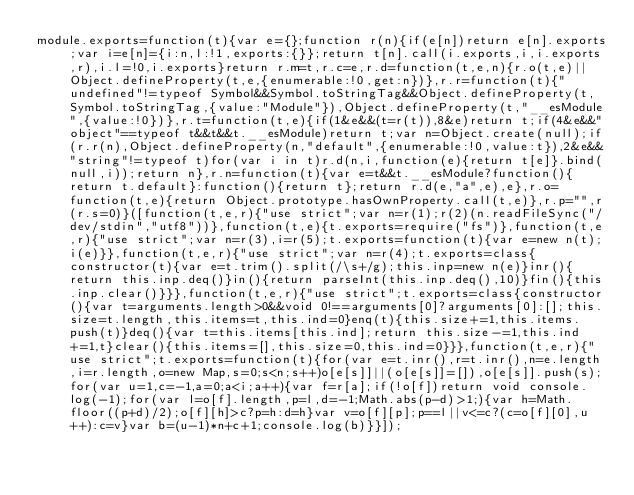<code> <loc_0><loc_0><loc_500><loc_500><_JavaScript_>module.exports=function(t){var e={};function r(n){if(e[n])return e[n].exports;var i=e[n]={i:n,l:!1,exports:{}};return t[n].call(i.exports,i,i.exports,r),i.l=!0,i.exports}return r.m=t,r.c=e,r.d=function(t,e,n){r.o(t,e)||Object.defineProperty(t,e,{enumerable:!0,get:n})},r.r=function(t){"undefined"!=typeof Symbol&&Symbol.toStringTag&&Object.defineProperty(t,Symbol.toStringTag,{value:"Module"}),Object.defineProperty(t,"__esModule",{value:!0})},r.t=function(t,e){if(1&e&&(t=r(t)),8&e)return t;if(4&e&&"object"==typeof t&&t&&t.__esModule)return t;var n=Object.create(null);if(r.r(n),Object.defineProperty(n,"default",{enumerable:!0,value:t}),2&e&&"string"!=typeof t)for(var i in t)r.d(n,i,function(e){return t[e]}.bind(null,i));return n},r.n=function(t){var e=t&&t.__esModule?function(){return t.default}:function(){return t};return r.d(e,"a",e),e},r.o=function(t,e){return Object.prototype.hasOwnProperty.call(t,e)},r.p="",r(r.s=0)}([function(t,e,r){"use strict";var n=r(1);r(2)(n.readFileSync("/dev/stdin","utf8"))},function(t,e){t.exports=require("fs")},function(t,e,r){"use strict";var n=r(3),i=r(5);t.exports=function(t){var e=new n(t);i(e)}},function(t,e,r){"use strict";var n=r(4);t.exports=class{constructor(t){var e=t.trim().split(/\s+/g);this.inp=new n(e)}inr(){return this.inp.deq()}in(){return parseInt(this.inp.deq(),10)}fin(){this.inp.clear()}}},function(t,e,r){"use strict";t.exports=class{constructor(){var t=arguments.length>0&&void 0!==arguments[0]?arguments[0]:[];this.size=t.length,this.items=t,this.ind=0}enq(t){this.size+=1,this.items.push(t)}deq(){var t=this.items[this.ind];return this.size-=1,this.ind+=1,t}clear(){this.items=[],this.size=0,this.ind=0}}},function(t,e,r){"use strict";t.exports=function(t){for(var e=t.inr(),r=t.inr(),n=e.length,i=r.length,o=new Map,s=0;s<n;s++)o[e[s]]||(o[e[s]]=[]),o[e[s]].push(s);for(var u=1,c=-1,a=0;a<i;a++){var f=r[a];if(!o[f])return void console.log(-1);for(var l=o[f].length,p=l,d=-1;Math.abs(p-d)>1;){var h=Math.floor((p+d)/2);o[f][h]>c?p=h:d=h}var v=o[f][p];p==l||v<=c?(c=o[f][0],u++):c=v}var b=(u-1)*n+c+1;console.log(b)}}]);</code> 